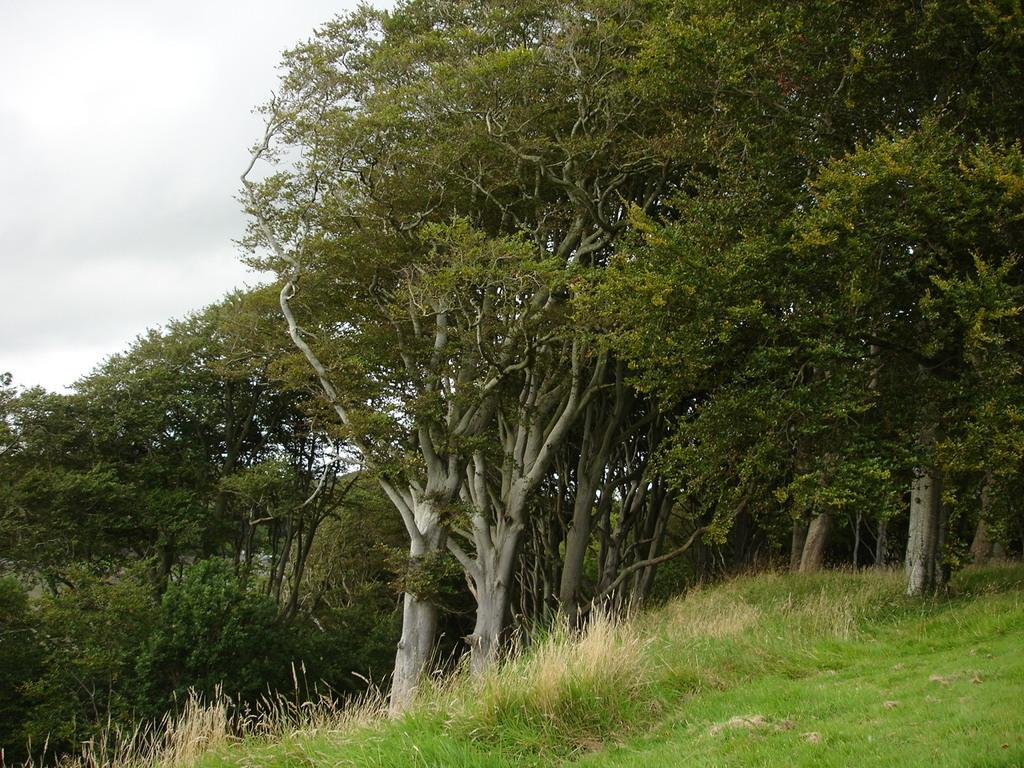What type of vegetation can be seen in the image? There are trees, grass, and plants in the image. What part of the natural environment is visible in the image? The sky is visible in the image. Can you describe the ground in the image? The ground in the image is covered with grass. How many mint leaves can be seen in the image? There is no mention of mint leaves in the image, so it is not possible to determine their presence or quantity. 